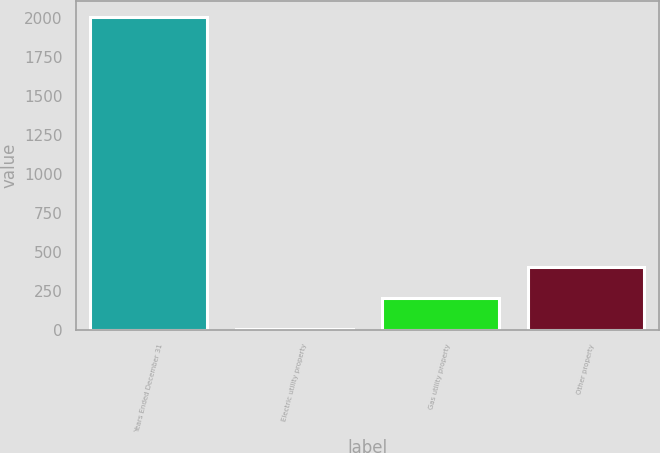Convert chart. <chart><loc_0><loc_0><loc_500><loc_500><bar_chart><fcel>Years Ended December 31<fcel>Electric utility property<fcel>Gas utility property<fcel>Other property<nl><fcel>2006<fcel>3.1<fcel>203.39<fcel>403.68<nl></chart> 